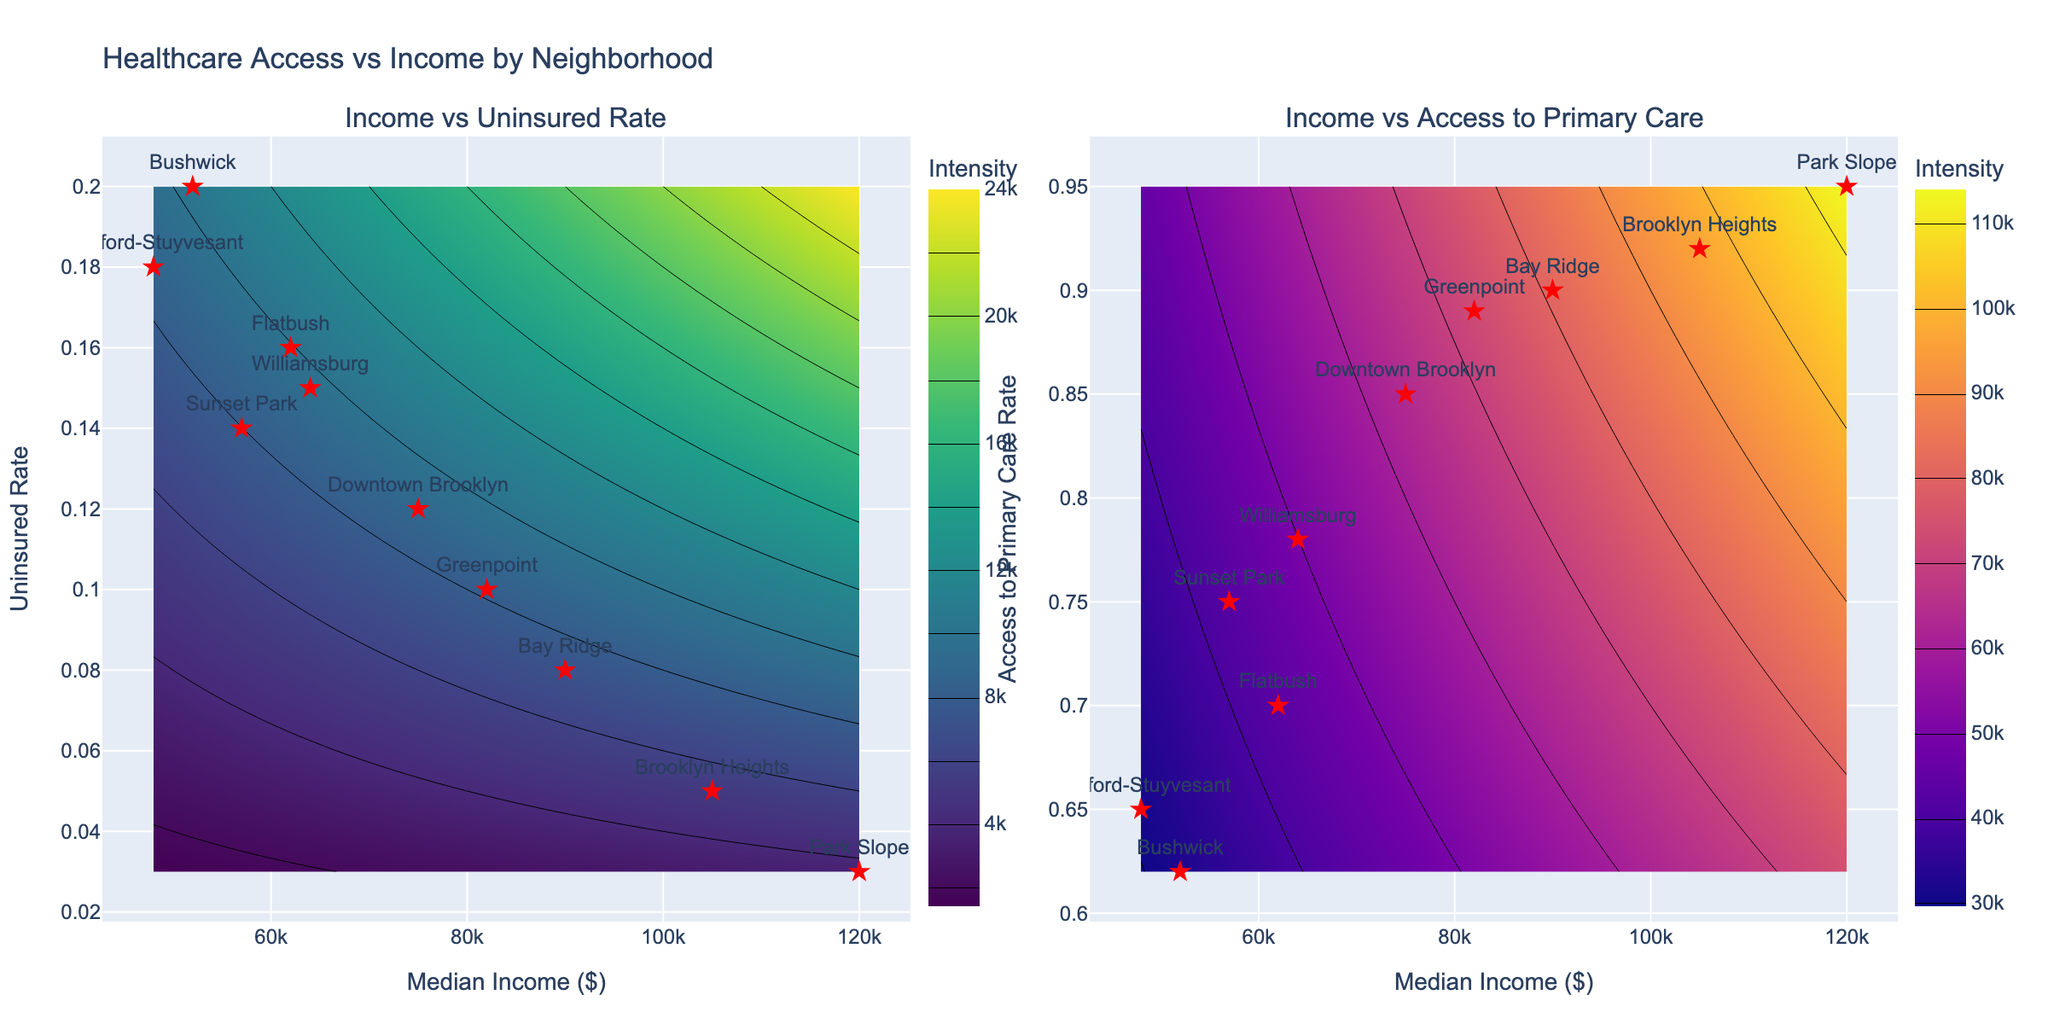What's the title of the plot? The title of the plot is typically located at the top of the figure. It gives an overview of what the figure is about.
Answer: Healthcare Access vs Income by Neighborhood What are the x-axis labels in both subplots? The x-axis labels in both subplots represent the same data and usually provide the variable being plotted on that axis. In this case, it is displayed at the bottom of each subplot.
Answer: Median Income ($) How many neighborhoods are shown in the plot? To determine the number of neighborhoods, count the unique marker labels (red stars) annotated with neighborhood names. There are individual points plotted for each neighborhood.
Answer: 10 Which neighborhood has the highest uninsured rate and what is it? Look at the left subplot, find the label with the highest position on the y-axis representing uninsured rate.
Answer: Bedford-Stuyvesant, 0.18 What is the relationship between median income and access to primary care rate illustrated in the plot? Examine the right subplot; note how the access to primary care rate changes as the median income increases by observing the overall trend and scatter of the data points.
Answer: Positive correlation Which neighborhood has the highest median income and what is its access to primary care rate? Identify the neighborhood with the highest value on the x-axis from either subplot and then check the corresponding y-axis value in the right subplot.
Answer: Park Slope, 0.95 Compare the uninsured rates of Bedford-Stuyvesant and Park Slope. Which one is higher and by how much? Find the uninsured rates for both neighborhoods in the left subplot and simply subtract the lower from the higher value.
Answer: Bedford-Stuyvesant is higher by 0.15 Does any neighborhood show a significant gap between access to primary care rate and uninsured rate? Compare the relative positions of neighborhoods in both subplots; if a neighborhood is high in one and low in another, it indicates a significant gap. For each, observe the y-axis values closely.
Answer: Bushwick shows a significant gap What color schemes are used for the two contour plots? Examine the color gradients in both subplots; they are usually indicated by the color bars next to each subplot.
Answer: Viridis for the left and Plasma for the right Identify a neighborhood with a median income close to $90000. What are its uninsured rate and access to primary care rate? Locate a neighborhood around the $90000 mark on the x-axis in both subplots, then check the corresponding y-axis values.
Answer: Bay Ridge, 0.08, 0.90 